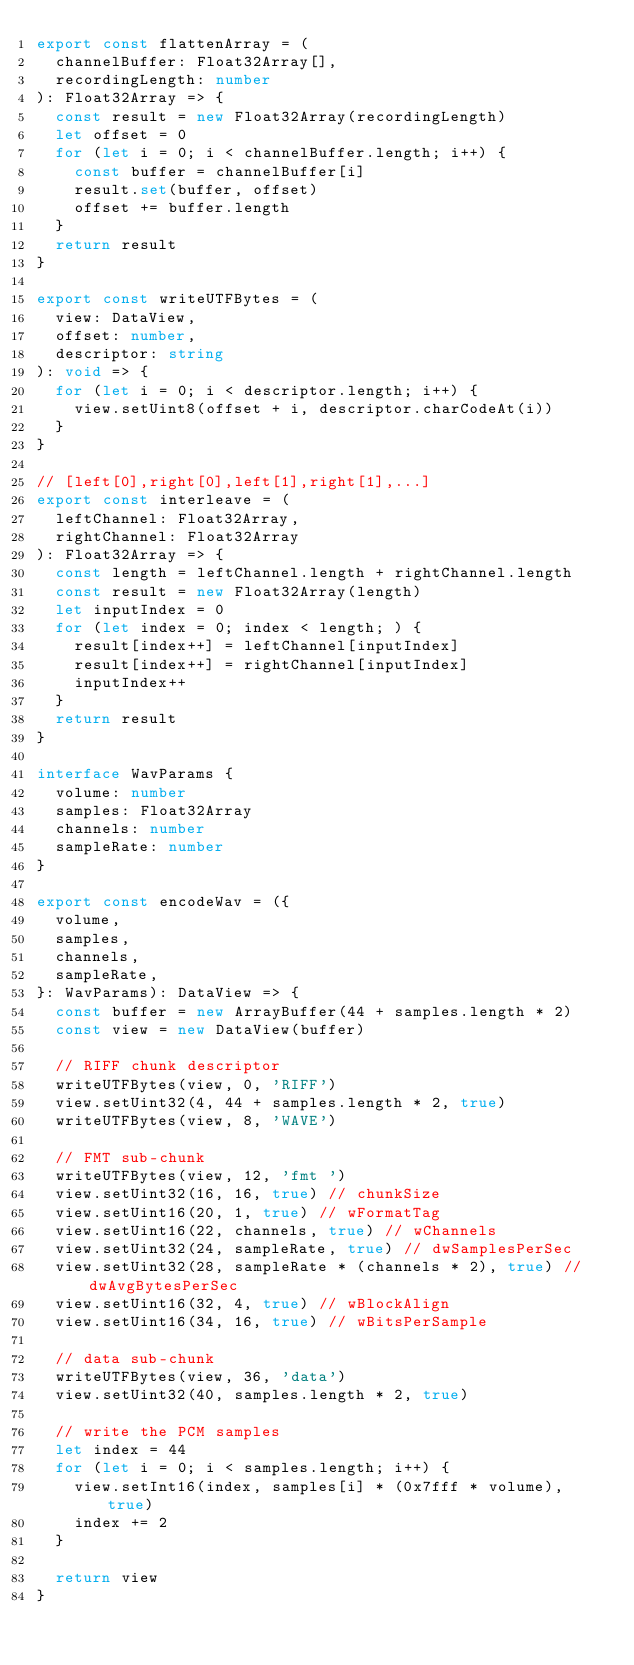<code> <loc_0><loc_0><loc_500><loc_500><_TypeScript_>export const flattenArray = (
  channelBuffer: Float32Array[],
  recordingLength: number
): Float32Array => {
  const result = new Float32Array(recordingLength)
  let offset = 0
  for (let i = 0; i < channelBuffer.length; i++) {
    const buffer = channelBuffer[i]
    result.set(buffer, offset)
    offset += buffer.length
  }
  return result
}

export const writeUTFBytes = (
  view: DataView,
  offset: number,
  descriptor: string
): void => {
  for (let i = 0; i < descriptor.length; i++) {
    view.setUint8(offset + i, descriptor.charCodeAt(i))
  }
}

// [left[0],right[0],left[1],right[1],...]
export const interleave = (
  leftChannel: Float32Array,
  rightChannel: Float32Array
): Float32Array => {
  const length = leftChannel.length + rightChannel.length
  const result = new Float32Array(length)
  let inputIndex = 0
  for (let index = 0; index < length; ) {
    result[index++] = leftChannel[inputIndex]
    result[index++] = rightChannel[inputIndex]
    inputIndex++
  }
  return result
}

interface WavParams {
  volume: number
  samples: Float32Array
  channels: number
  sampleRate: number
}

export const encodeWav = ({
  volume,
  samples,
  channels,
  sampleRate,
}: WavParams): DataView => {
  const buffer = new ArrayBuffer(44 + samples.length * 2)
  const view = new DataView(buffer)

  // RIFF chunk descriptor
  writeUTFBytes(view, 0, 'RIFF')
  view.setUint32(4, 44 + samples.length * 2, true)
  writeUTFBytes(view, 8, 'WAVE')

  // FMT sub-chunk
  writeUTFBytes(view, 12, 'fmt ')
  view.setUint32(16, 16, true) // chunkSize
  view.setUint16(20, 1, true) // wFormatTag
  view.setUint16(22, channels, true) // wChannels
  view.setUint32(24, sampleRate, true) // dwSamplesPerSec
  view.setUint32(28, sampleRate * (channels * 2), true) // dwAvgBytesPerSec
  view.setUint16(32, 4, true) // wBlockAlign
  view.setUint16(34, 16, true) // wBitsPerSample

  // data sub-chunk
  writeUTFBytes(view, 36, 'data')
  view.setUint32(40, samples.length * 2, true)

  // write the PCM samples
  let index = 44
  for (let i = 0; i < samples.length; i++) {
    view.setInt16(index, samples[i] * (0x7fff * volume), true)
    index += 2
  }

  return view
}
</code> 